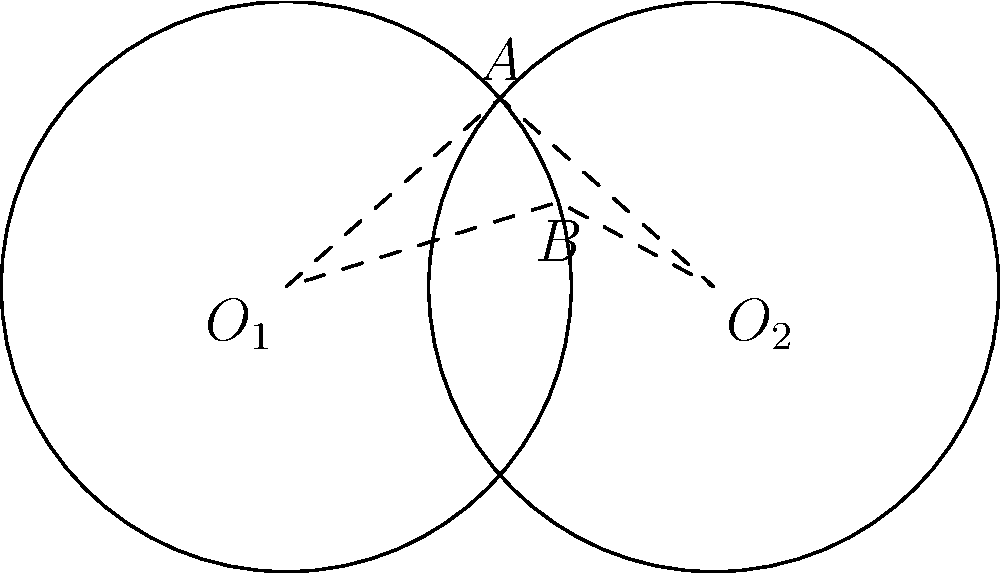In a contract dispute case, you're presented with a diagram representing two overlapping circular properties. Each circle has a radius of 2 units, and their centers are 3 units apart. What is the area of the region where the properties overlap (shaded area)? Round your answer to two decimal places. Let's approach this step-by-step:

1) First, we need to find the area of the lens-shaped region formed by the intersection of the two circles.

2) The formula for this area is:
   $$A = 2r^2 \arccos(\frac{d}{2r}) - d\sqrt{r^2 - (\frac{d}{2})^2}$$
   where $r$ is the radius of each circle and $d$ is the distance between their centers.

3) We're given:
   $r = 2$ units
   $d = 3$ units

4) Let's substitute these values:
   $$A = 2(2^2) \arccos(\frac{3}{2(2)}) - 3\sqrt{2^2 - (\frac{3}{2})^2}$$

5) Simplify:
   $$A = 8 \arccos(\frac{3}{4}) - 3\sqrt{4 - \frac{9}{4}}$$
   $$A = 8 \arccos(\frac{3}{4}) - 3\sqrt{\frac{7}{4}}$$

6) Calculate:
   $$A \approx 8(0.7227) - 3(1.3229)$$
   $$A \approx 5.7816 - 3.9687$$
   $$A \approx 1.8129$$

7) Rounding to two decimal places:
   $$A \approx 1.81$$ square units
Answer: 1.81 square units 